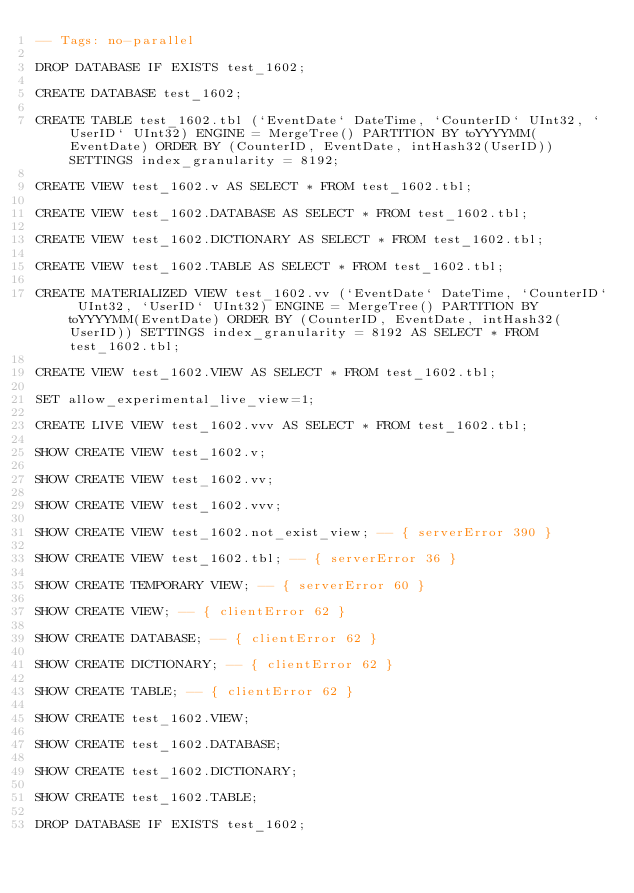<code> <loc_0><loc_0><loc_500><loc_500><_SQL_>-- Tags: no-parallel

DROP DATABASE IF EXISTS test_1602;

CREATE DATABASE test_1602;

CREATE TABLE test_1602.tbl (`EventDate` DateTime, `CounterID` UInt32, `UserID` UInt32) ENGINE = MergeTree() PARTITION BY toYYYYMM(EventDate) ORDER BY (CounterID, EventDate, intHash32(UserID)) SETTINGS index_granularity = 8192;

CREATE VIEW test_1602.v AS SELECT * FROM test_1602.tbl; 

CREATE VIEW test_1602.DATABASE AS SELECT * FROM test_1602.tbl; 

CREATE VIEW test_1602.DICTIONARY AS SELECT * FROM test_1602.tbl; 

CREATE VIEW test_1602.TABLE AS SELECT * FROM test_1602.tbl; 

CREATE MATERIALIZED VIEW test_1602.vv (`EventDate` DateTime, `CounterID` UInt32, `UserID` UInt32) ENGINE = MergeTree() PARTITION BY toYYYYMM(EventDate) ORDER BY (CounterID, EventDate, intHash32(UserID)) SETTINGS index_granularity = 8192 AS SELECT * FROM test_1602.tbl;

CREATE VIEW test_1602.VIEW AS SELECT * FROM test_1602.tbl; 

SET allow_experimental_live_view=1;

CREATE LIVE VIEW test_1602.vvv AS SELECT * FROM test_1602.tbl;

SHOW CREATE VIEW test_1602.v;

SHOW CREATE VIEW test_1602.vv;

SHOW CREATE VIEW test_1602.vvv;

SHOW CREATE VIEW test_1602.not_exist_view; -- { serverError 390 }

SHOW CREATE VIEW test_1602.tbl; -- { serverError 36 }

SHOW CREATE TEMPORARY VIEW; -- { serverError 60 }

SHOW CREATE VIEW; -- { clientError 62 }

SHOW CREATE DATABASE; -- { clientError 62 }

SHOW CREATE DICTIONARY; -- { clientError 62 }

SHOW CREATE TABLE; -- { clientError 62 }

SHOW CREATE test_1602.VIEW;

SHOW CREATE test_1602.DATABASE;

SHOW CREATE test_1602.DICTIONARY;

SHOW CREATE test_1602.TABLE;

DROP DATABASE IF EXISTS test_1602;
</code> 